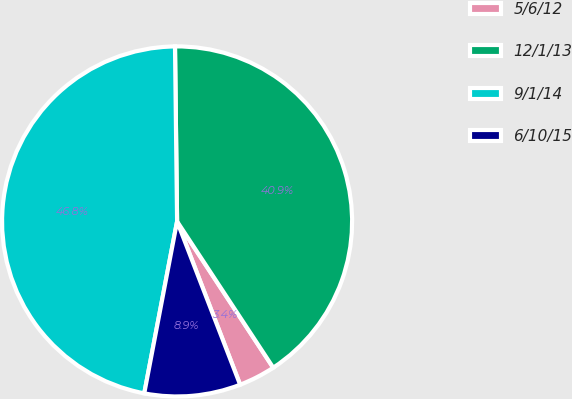Convert chart to OTSL. <chart><loc_0><loc_0><loc_500><loc_500><pie_chart><fcel>5/6/12<fcel>12/1/13<fcel>9/1/14<fcel>6/10/15<nl><fcel>3.39%<fcel>40.94%<fcel>46.81%<fcel>8.87%<nl></chart> 